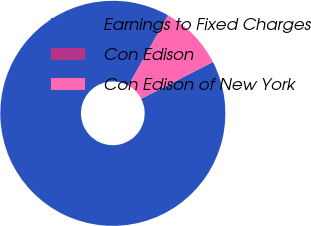<chart> <loc_0><loc_0><loc_500><loc_500><pie_chart><fcel>Earnings to Fixed Charges<fcel>Con Edison<fcel>Con Edison of New York<nl><fcel>90.67%<fcel>0.14%<fcel>9.19%<nl></chart> 